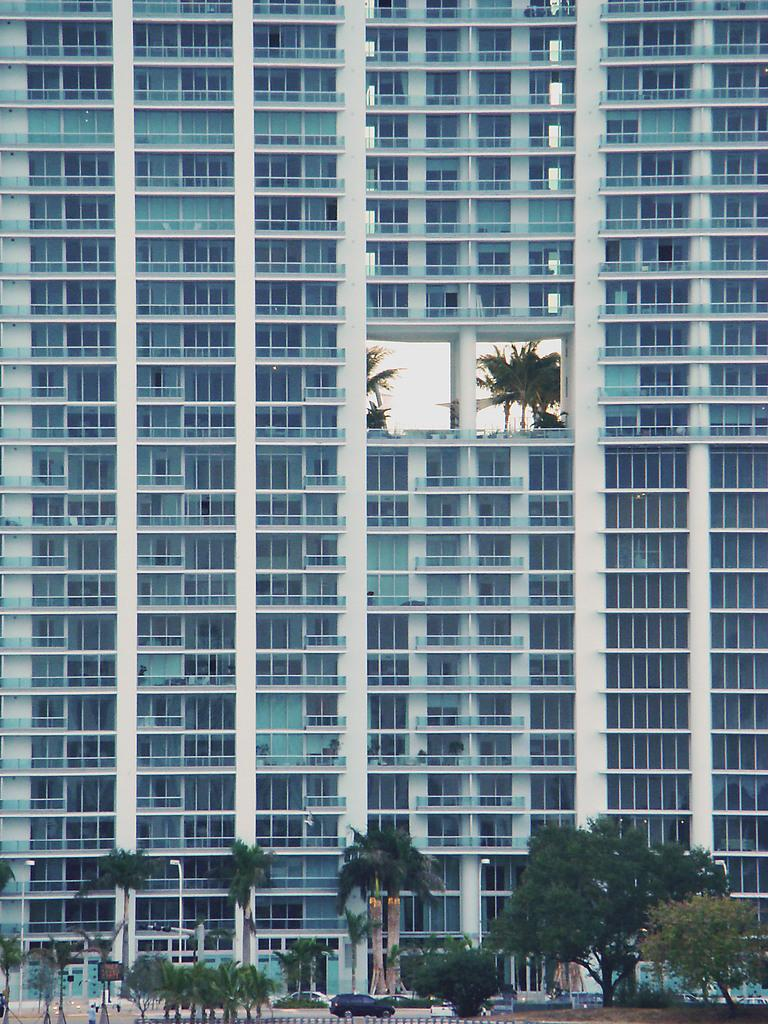What type of natural elements can be seen in the image? There are trees in the image. What man-made objects are present in the image? There are vehicles, poles, a building, and people in the image. Can you describe the building in the image? The building has windows and a railing. What is visible in the middle of the image? The middle of the image contains trees. What part of the natural environment is visible in the image? The sky is visible in the image. What color is the copper edge of the building in the image? There is no copper edge present in the image; the building does not have a copper edge. How does the quiet atmosphere in the image affect the people? There is no mention of a quiet atmosphere in the image, so it cannot be determined how it affects the people. 